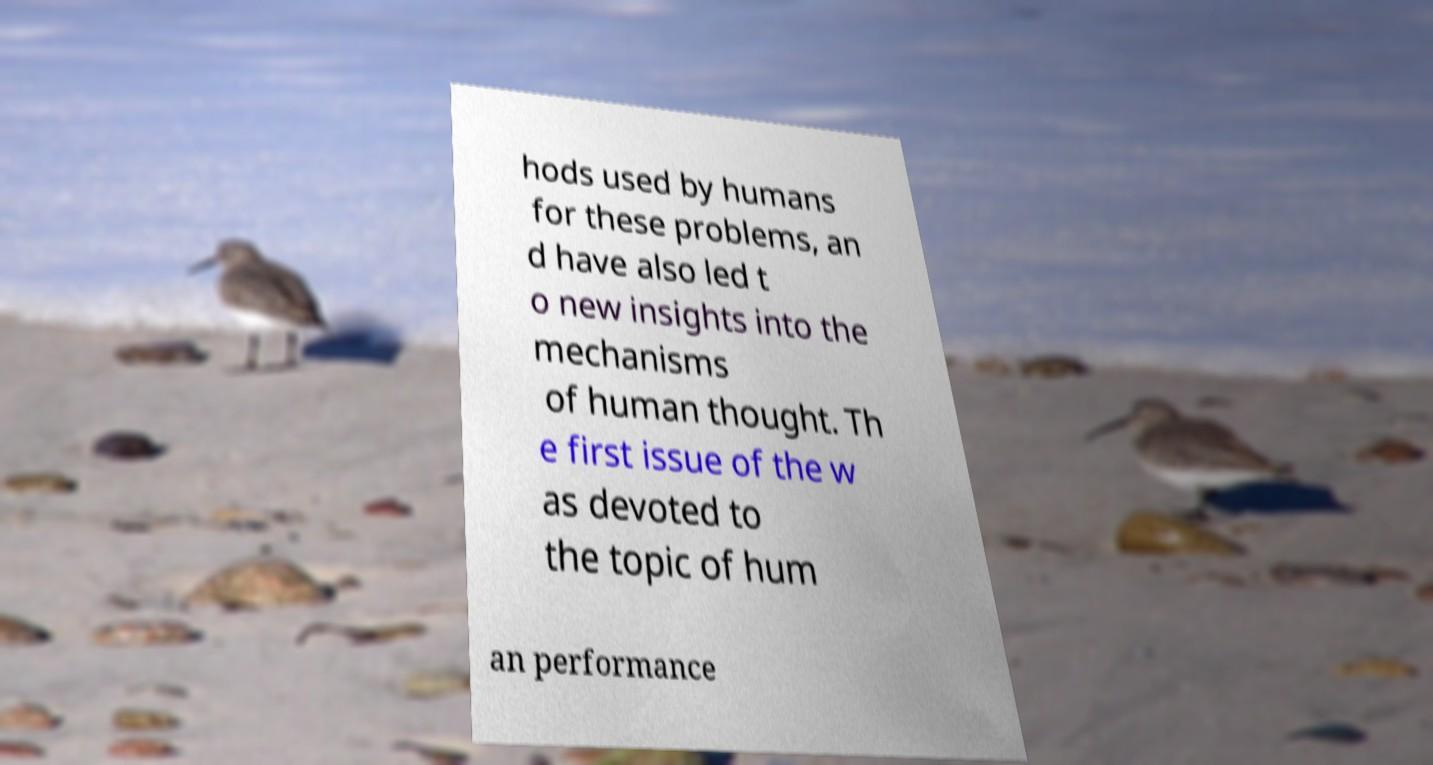Please read and relay the text visible in this image. What does it say? hods used by humans for these problems, an d have also led t o new insights into the mechanisms of human thought. Th e first issue of the w as devoted to the topic of hum an performance 